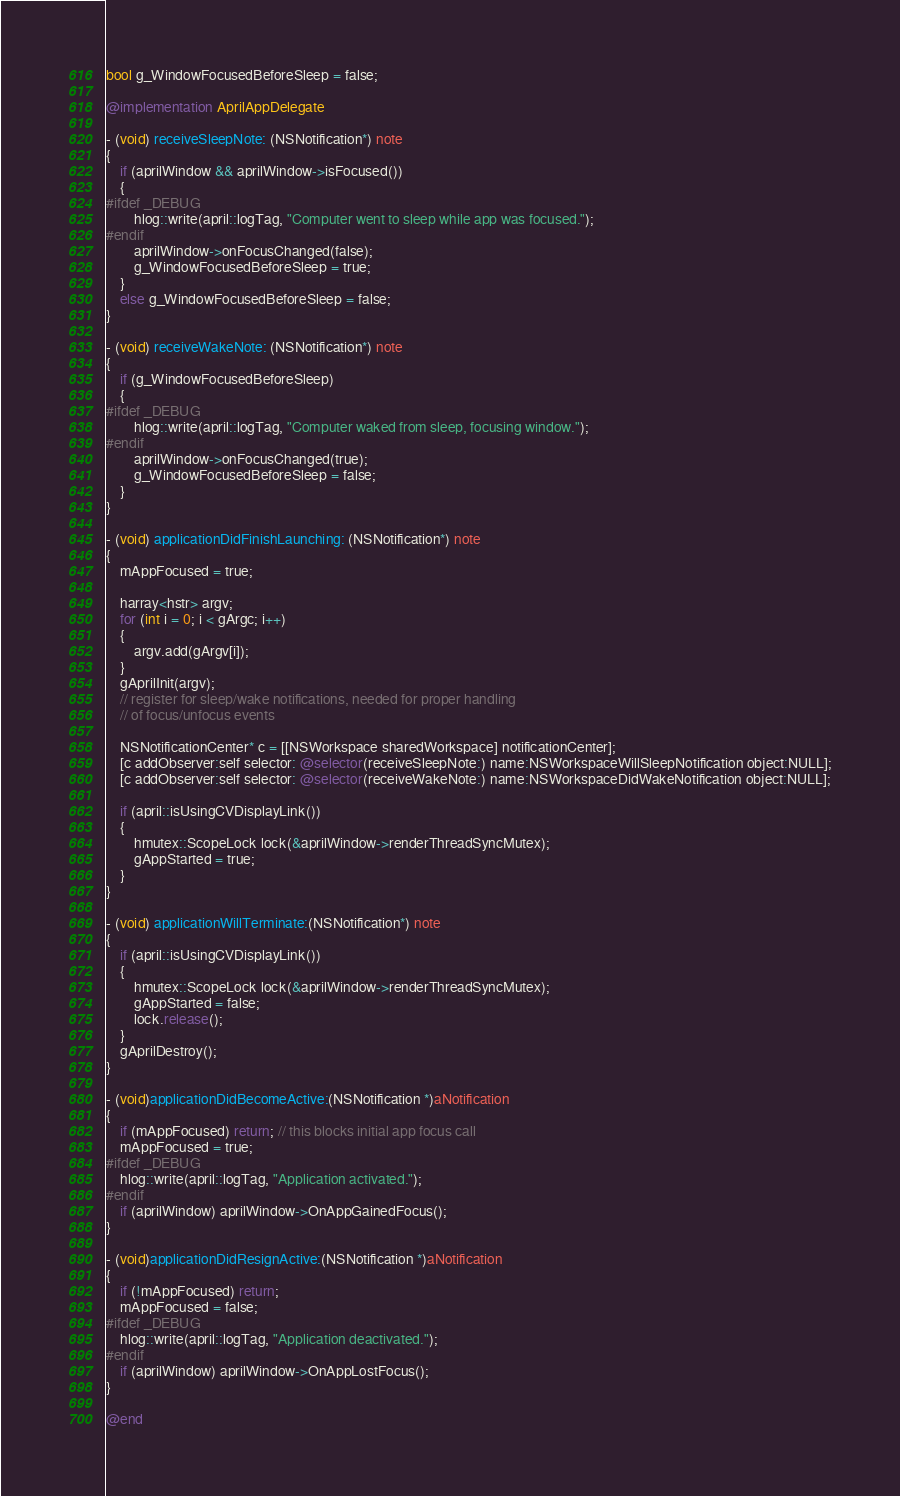Convert code to text. <code><loc_0><loc_0><loc_500><loc_500><_ObjectiveC_>bool g_WindowFocusedBeforeSleep = false;

@implementation AprilAppDelegate

- (void) receiveSleepNote: (NSNotification*) note
{
	if (aprilWindow && aprilWindow->isFocused())
	{
#ifdef _DEBUG
		hlog::write(april::logTag, "Computer went to sleep while app was focused.");
#endif
		aprilWindow->onFocusChanged(false);
		g_WindowFocusedBeforeSleep = true;
	}
	else g_WindowFocusedBeforeSleep = false;
}

- (void) receiveWakeNote: (NSNotification*) note
{
	if (g_WindowFocusedBeforeSleep)
	{
#ifdef _DEBUG
		hlog::write(april::logTag, "Computer waked from sleep, focusing window.");
#endif
		aprilWindow->onFocusChanged(true);
		g_WindowFocusedBeforeSleep = false;
	}
}

- (void) applicationDidFinishLaunching: (NSNotification*) note
{
	mAppFocused = true;

	harray<hstr> argv;
	for (int i = 0; i < gArgc; i++)
	{
		argv.add(gArgv[i]);
	}
	gAprilInit(argv);
	// register for sleep/wake notifications, needed for proper handling
	// of focus/unfocus events
	
	NSNotificationCenter* c = [[NSWorkspace sharedWorkspace] notificationCenter];
	[c addObserver:self selector: @selector(receiveSleepNote:) name:NSWorkspaceWillSleepNotification object:NULL];
	[c addObserver:self selector: @selector(receiveWakeNote:) name:NSWorkspaceDidWakeNotification object:NULL];
    
    if (april::isUsingCVDisplayLink())
    {
        hmutex::ScopeLock lock(&aprilWindow->renderThreadSyncMutex);
        gAppStarted = true;
    }
}

- (void) applicationWillTerminate:(NSNotification*) note
{
    if (april::isUsingCVDisplayLink())
    {
        hmutex::ScopeLock lock(&aprilWindow->renderThreadSyncMutex);
        gAppStarted = false;
        lock.release();
    }
	gAprilDestroy();
}

- (void)applicationDidBecomeActive:(NSNotification *)aNotification
{
	if (mAppFocused) return; // this blocks initial app focus call
	mAppFocused = true;
#ifdef _DEBUG
	hlog::write(april::logTag, "Application activated.");
#endif
	if (aprilWindow) aprilWindow->OnAppGainedFocus();
}

- (void)applicationDidResignActive:(NSNotification *)aNotification
{
	if (!mAppFocused) return;
	mAppFocused = false;
#ifdef _DEBUG
	hlog::write(april::logTag, "Application deactivated.");
#endif
	if (aprilWindow) aprilWindow->OnAppLostFocus();
}

@end
</code> 